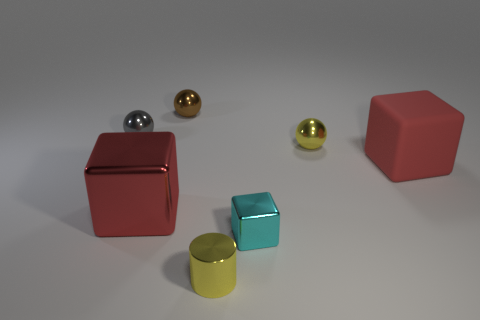How many other objects are there of the same size as the cyan thing?
Your answer should be very brief. 4. How many objects are either red cubes that are on the right side of the small cylinder or small spheres?
Make the answer very short. 4. The brown thing that is made of the same material as the tiny yellow sphere is what shape?
Provide a succinct answer. Sphere. What number of other small metal objects are the same shape as the tiny cyan metal thing?
Your answer should be very brief. 0. What is the yellow sphere made of?
Keep it short and to the point. Metal. Do the tiny metal cylinder and the large block in front of the red rubber cube have the same color?
Give a very brief answer. No. How many balls are yellow metal things or gray objects?
Ensure brevity in your answer.  2. There is a sphere that is in front of the gray shiny sphere; what is its color?
Your response must be concise. Yellow. There is a tiny thing that is the same color as the small cylinder; what is its shape?
Make the answer very short. Sphere. What number of yellow metallic cylinders are the same size as the rubber cube?
Your answer should be very brief. 0. 